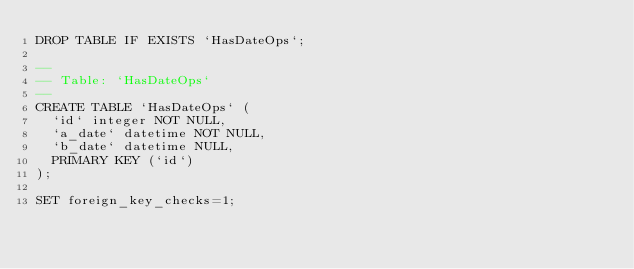Convert code to text. <code><loc_0><loc_0><loc_500><loc_500><_SQL_>DROP TABLE IF EXISTS `HasDateOps`;

--
-- Table: `HasDateOps`
--
CREATE TABLE `HasDateOps` (
  `id` integer NOT NULL,
  `a_date` datetime NOT NULL,
  `b_date` datetime NULL,
  PRIMARY KEY (`id`)
);

SET foreign_key_checks=1;

</code> 